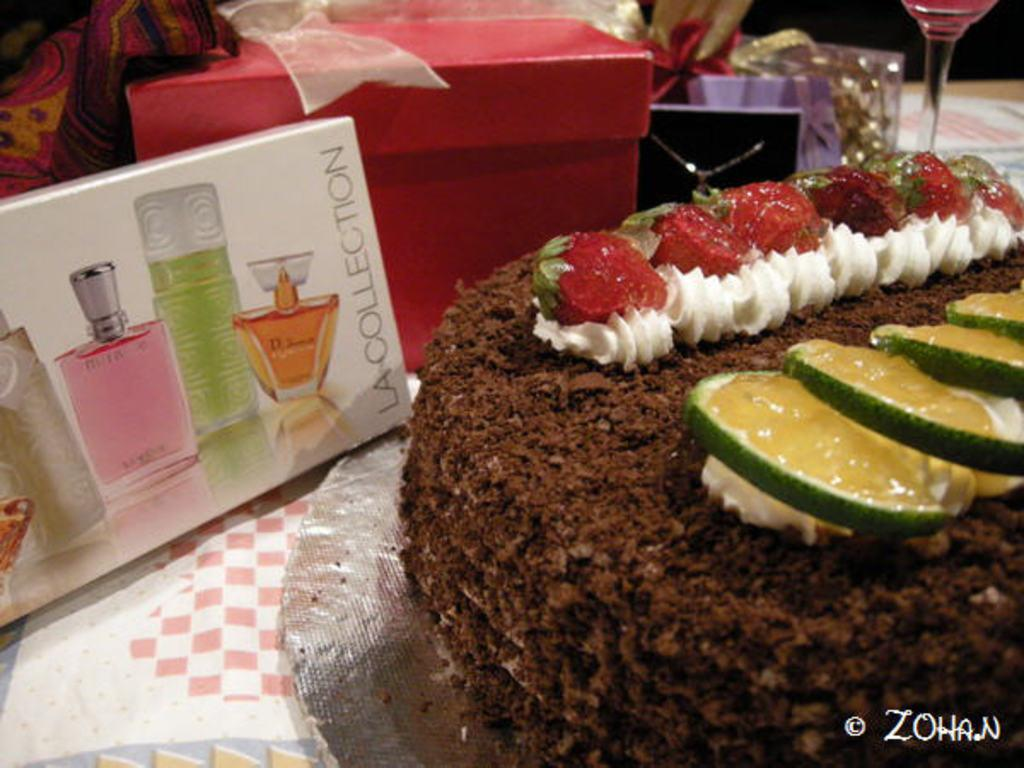<image>
Render a clear and concise summary of the photo. Some sort of a dessert topped with fruit and it says zohan in the corner. 